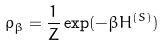<formula> <loc_0><loc_0><loc_500><loc_500>\rho _ { \beta } = \frac { 1 } { Z } \exp ( - \beta H ^ { ( S ) } )</formula> 